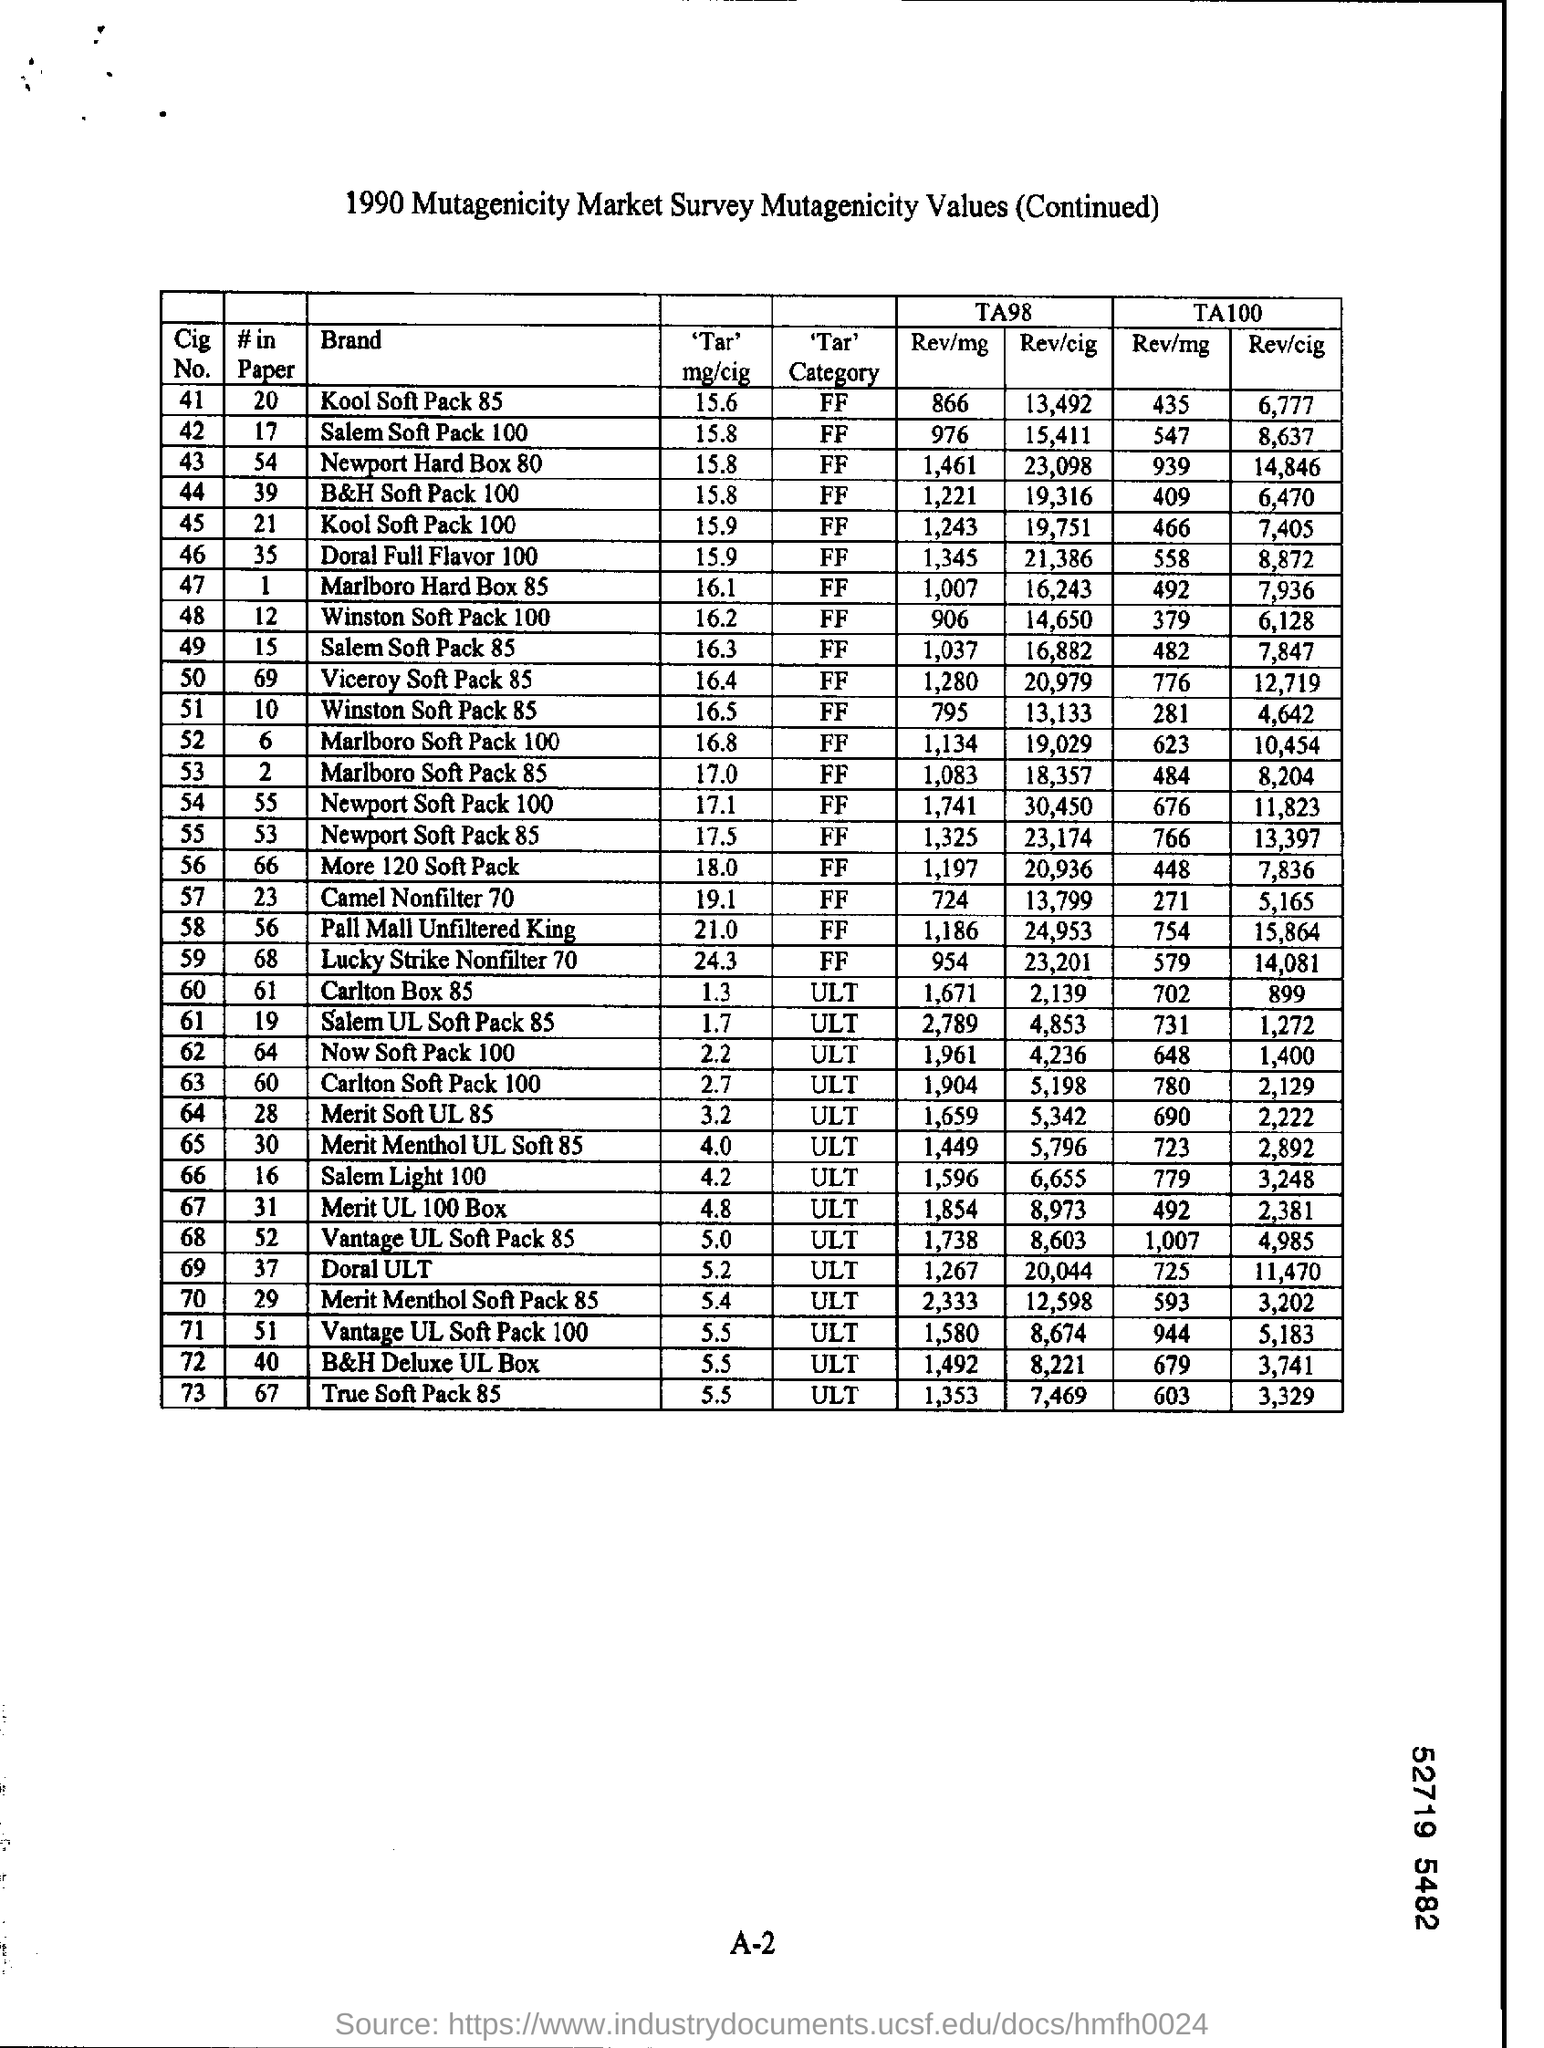Identify some key points in this picture. The cost of Cigarette No. 41 in #in paper is 20...". 